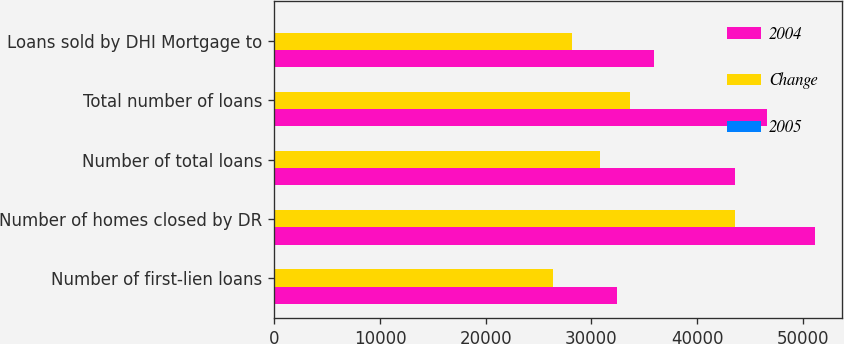Convert chart. <chart><loc_0><loc_0><loc_500><loc_500><stacked_bar_chart><ecel><fcel>Number of first-lien loans<fcel>Number of homes closed by DR<fcel>Number of total loans<fcel>Total number of loans<fcel>Loans sold by DHI Mortgage to<nl><fcel>2004<fcel>32404<fcel>51172<fcel>43581<fcel>46648<fcel>35962<nl><fcel>Change<fcel>26387<fcel>43567<fcel>30801<fcel>33621<fcel>28173<nl><fcel>2005<fcel>23<fcel>17<fcel>41<fcel>39<fcel>28<nl></chart> 